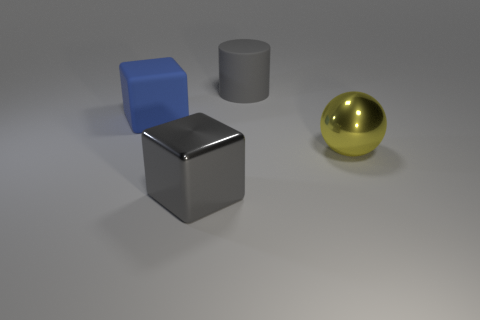Does the matte cylinder have the same color as the metallic block?
Make the answer very short. Yes. What is the material of the blue block that is the same size as the gray cylinder?
Make the answer very short. Rubber. The big ball has what color?
Offer a very short reply. Yellow. There is a big cube that is the same color as the matte cylinder; what is it made of?
Your answer should be very brief. Metal. What number of other things are there of the same shape as the big gray metal thing?
Your answer should be compact. 1. Does the cube left of the gray cube have the same material as the big cylinder?
Keep it short and to the point. Yes. Is the number of large yellow spheres on the left side of the gray matte cylinder the same as the number of big gray objects that are in front of the big metal ball?
Your response must be concise. No. Are there any big yellow objects that have the same material as the big gray cube?
Your response must be concise. Yes. Do the metallic object in front of the yellow sphere and the matte cylinder have the same color?
Provide a short and direct response. Yes. Is the number of large rubber blocks that are on the right side of the big matte cylinder the same as the number of small green shiny objects?
Provide a short and direct response. Yes. 